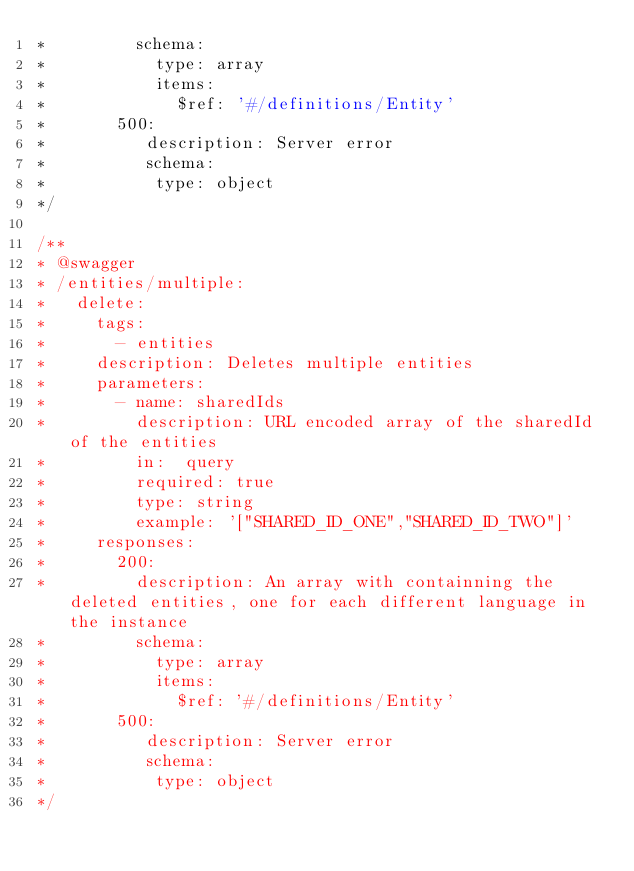<code> <loc_0><loc_0><loc_500><loc_500><_JavaScript_>*         schema:
*           type: array
*           items:
*             $ref: '#/definitions/Entity'
*       500:
*          description: Server error
*          schema:
*           type: object
*/

/**
* @swagger
* /entities/multiple:
*   delete:
*     tags:
*       - entities
*     description: Deletes multiple entities
*     parameters:
*       - name: sharedIds
*         description: URL encoded array of the sharedId of the entities
*         in:  query
*         required: true
*         type: string
*         example: '["SHARED_ID_ONE","SHARED_ID_TWO"]'
*     responses:
*       200:
*         description: An array with containning the deleted entities, one for each different language in the instance
*         schema:
*           type: array
*           items:
*             $ref: '#/definitions/Entity'
*       500:
*          description: Server error
*          schema:
*           type: object
*/
</code> 